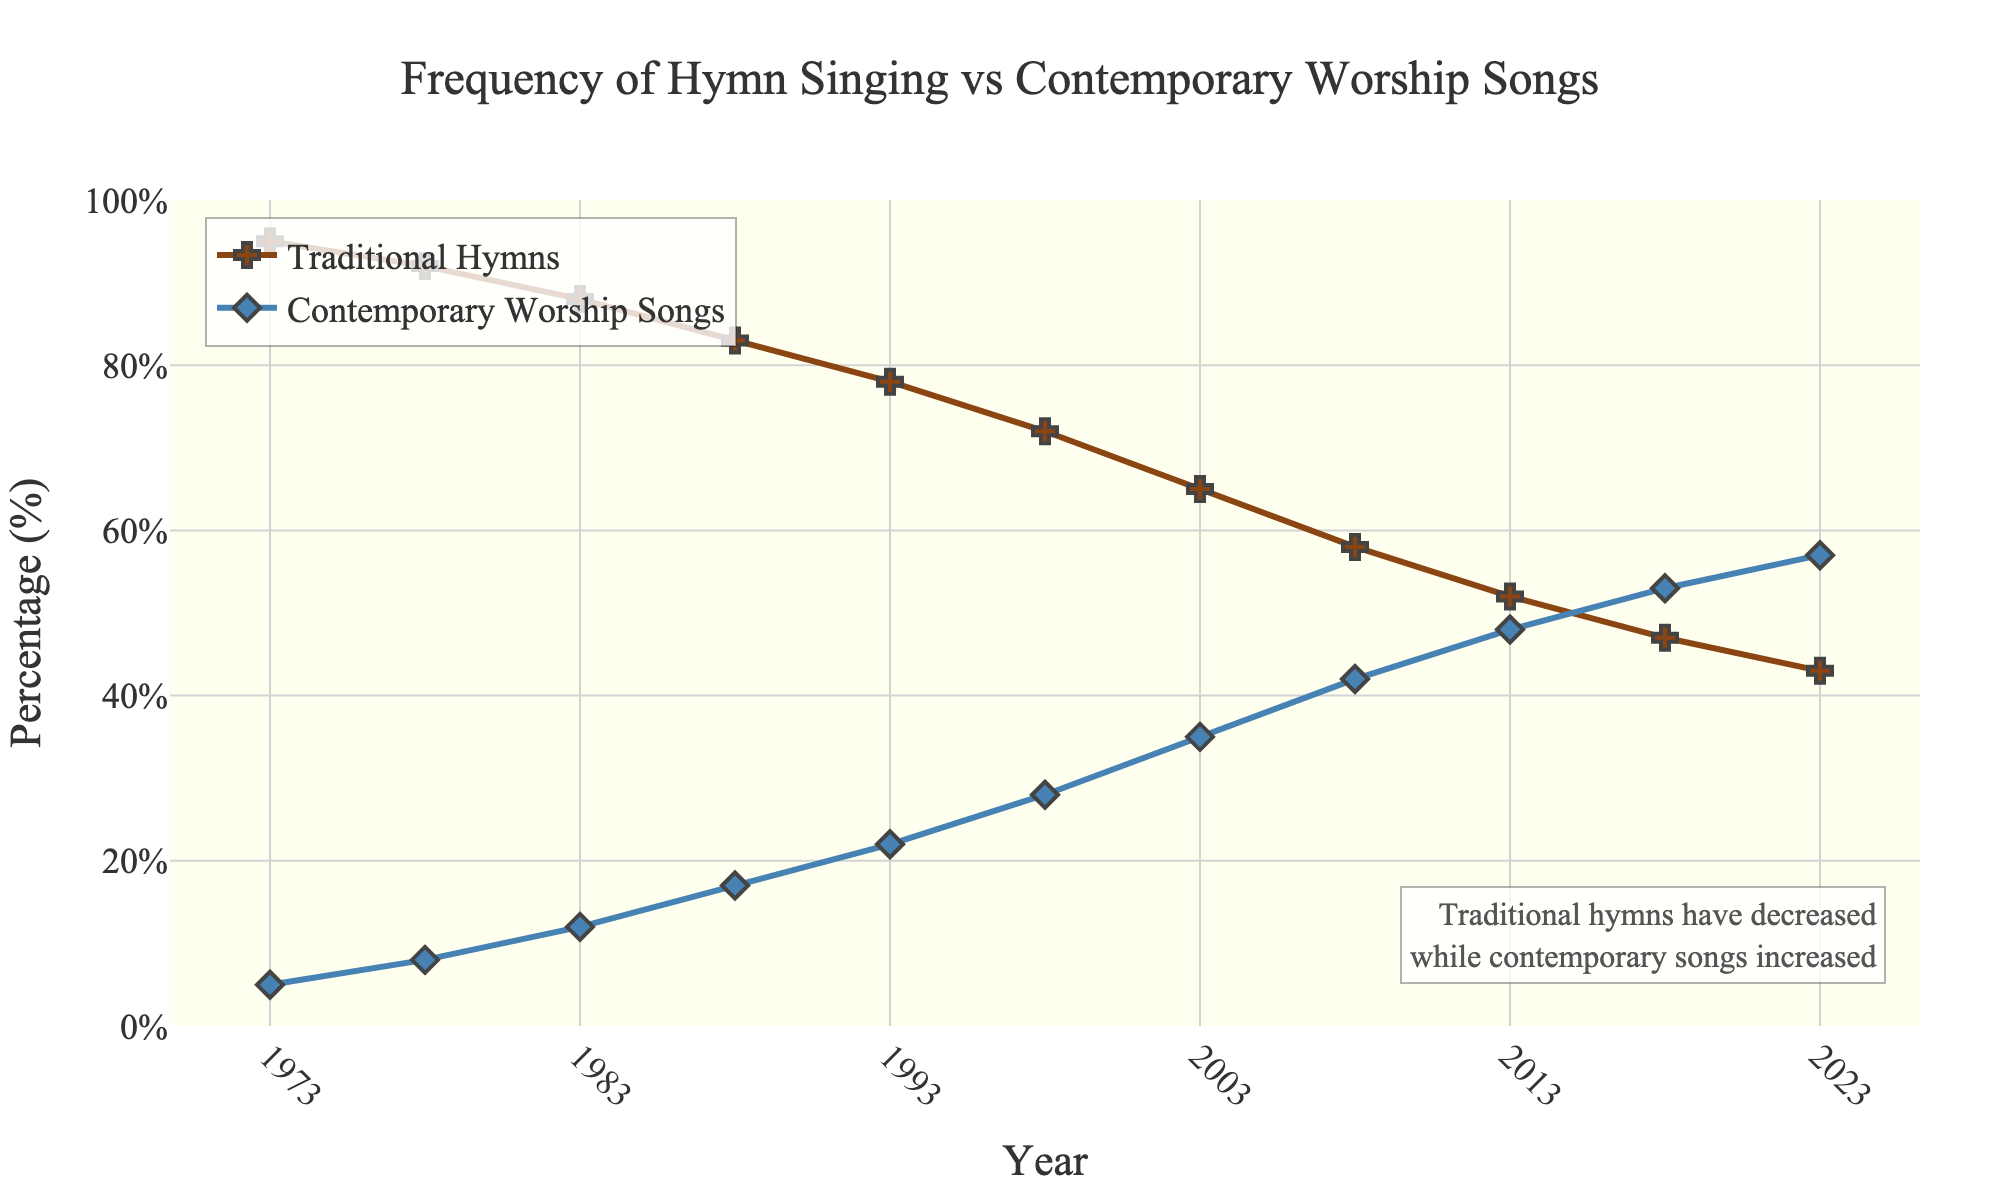What percentage of services included traditional hymns in 1973? Look at the point labeled 1973 on the 'Traditional Hymns' line. The value next to that point indicates the percentage.
Answer: 95% What is the percentage difference in the frequency of contemporary worship songs between 2003 and 2023? Find the data points for contemporary worship songs for the years 2003 and 2023. Subtract the 2003 value from the 2023 value: 57% - 35% = 22%
Answer: 22% How did the frequency of traditional hymns change from 1988 to 1998? Identify the values for 1988 and 1998 from the 'Traditional Hymns' line. The percentage in 1988 was 83%, and in 1998 was 72%. Calculate the difference: 83% - 72% = 11%.
Answer: Decreased by 11% Which type of music was more frequently used in 2013, and by how much? For 2013, compare the values for 'Traditional Hymns' and 'Contemporary Worship Songs'. Traditional hymns were at 52%, and contemporary worship songs were at 48%. Subtract 48% from 52%: 52% - 48% = 4%.
Answer: Traditional hymns by 4% By what year did contemporary worship songs equal traditional hymns in frequency? Identify the year where the lines for 'Traditional Hymns' and 'Contemporary Worship Songs' intersect each other. This intersection occurs at 50%.
Answer: Around 2013 What is the overall trend in the frequency of traditional hymns over the period shown? Observe the entire 'Traditional Hymns' line from 1973 to 2023. The line generally descends, indicating a decrease.
Answer: Decreasing Compare the frequency of contemporary worship songs in 1993 and 2013. Which year had higher usage, and by how much? Find the data points for contemporary worship songs for 1993 and 2013. The values are 22% for 1993 and 48% for 2013. Subtract 22% from 48%: 48% - 22% = 26%.
Answer: 2013 by 26% What pattern is observed in the frequencies of traditional hymns and contemporary worship songs from 1973 to 2023? Examine the 'Traditional Hymns' and 'Contemporary Worship Songs' lines from 1973 to 2023. Traditional hymns continuously decrease while contemporary worship songs continuously increase.
Answer: Opposite trends In which year was the difference between the frequencies of traditional hymns and contemporary worship songs the smallest? Check the points where the distance between the 'Traditional Hymns' and 'Contemporary Worship Songs' lines are closest. This is when they intersect around 2013.
Answer: 2013 